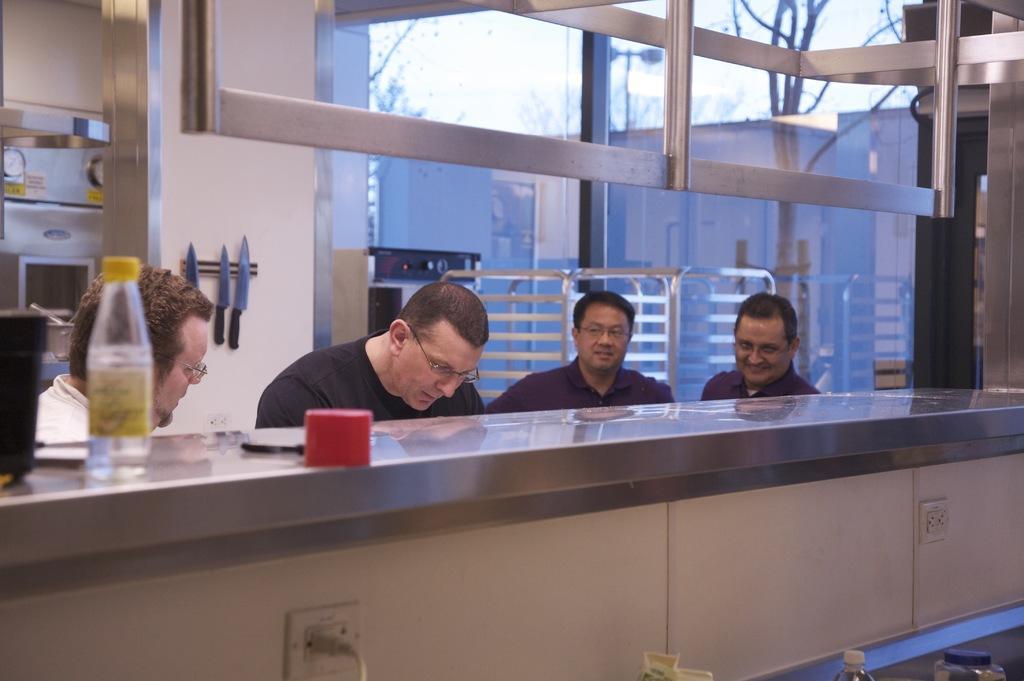Can you describe this image briefly? This picture is taken inside the room. In this image, we can see four people are sitting in front of the table. On the left side of the table, we can see a bottle, cap and a jar. In the background, we can see some knives which are attached to a wall, microwave oven, glass window. Outside of the glass window, we can see some buildings, trees, street lights and a sky. In the right corner, we can see a bottle and jar. 